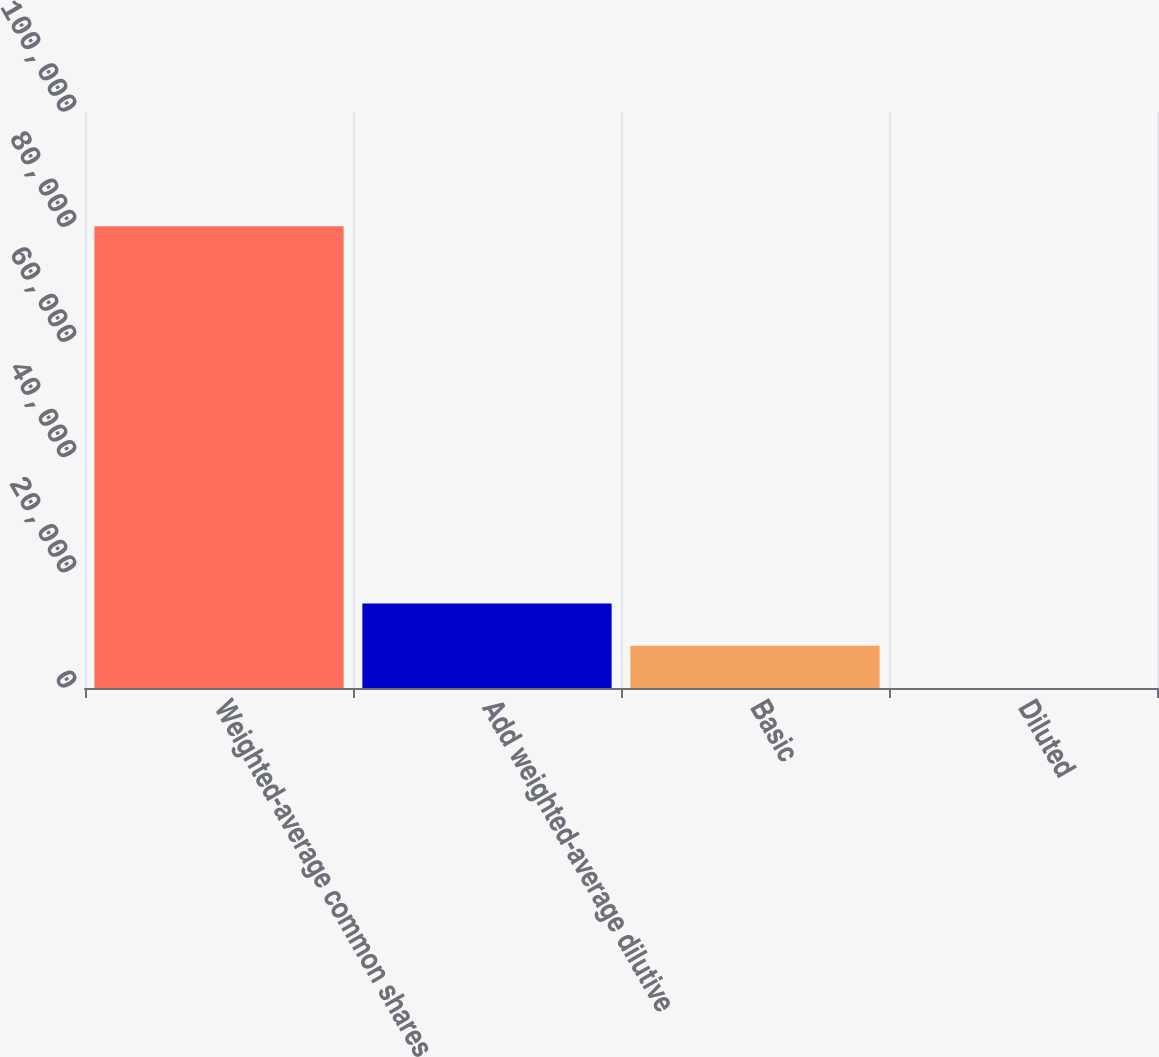<chart> <loc_0><loc_0><loc_500><loc_500><bar_chart><fcel>Weighted-average common shares<fcel>Add weighted-average dilutive<fcel>Basic<fcel>Diluted<nl><fcel>80172.6<fcel>14678.4<fcel>7342.83<fcel>7.25<nl></chart> 